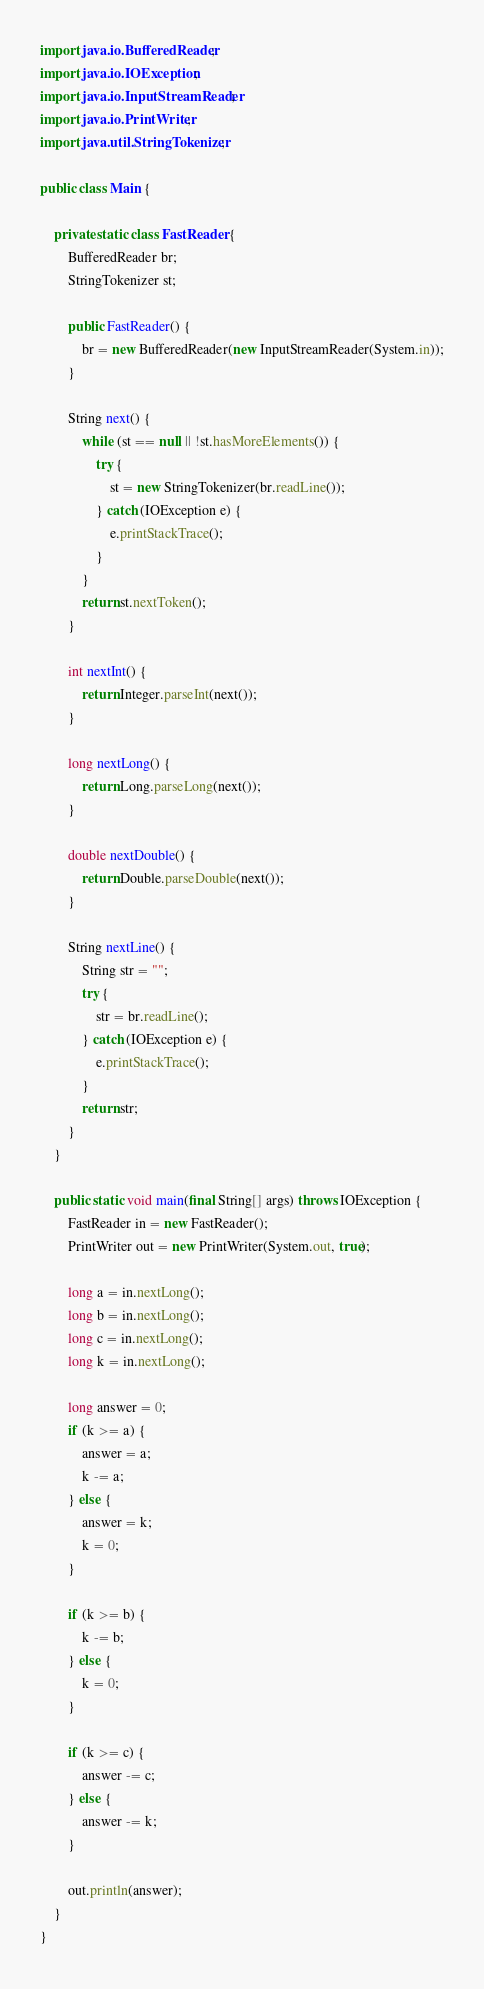Convert code to text. <code><loc_0><loc_0><loc_500><loc_500><_Java_>import java.io.BufferedReader;
import java.io.IOException;
import java.io.InputStreamReader;
import java.io.PrintWriter;
import java.util.StringTokenizer;

public class Main {

    private static class FastReader {
        BufferedReader br;
        StringTokenizer st;

        public FastReader() {
            br = new BufferedReader(new InputStreamReader(System.in));
        }

        String next() {
            while (st == null || !st.hasMoreElements()) {
                try {
                    st = new StringTokenizer(br.readLine());
                } catch (IOException e) {
                    e.printStackTrace();
                }
            }
            return st.nextToken();
        }

        int nextInt() {
            return Integer.parseInt(next());
        }

        long nextLong() {
            return Long.parseLong(next());
        }

        double nextDouble() {
            return Double.parseDouble(next());
        }

        String nextLine() {
            String str = "";
            try {
                str = br.readLine();
            } catch (IOException e) {
                e.printStackTrace();
            }
            return str;
        }
    }

    public static void main(final String[] args) throws IOException {
        FastReader in = new FastReader();
        PrintWriter out = new PrintWriter(System.out, true);

        long a = in.nextLong();
        long b = in.nextLong();
        long c = in.nextLong();
        long k = in.nextLong();

        long answer = 0;
        if (k >= a) {
            answer = a;
            k -= a;
        } else {
            answer = k;
            k = 0;
        }

        if (k >= b) {
            k -= b;
        } else {
            k = 0;
        }

        if (k >= c) {
            answer -= c;
        } else {
            answer -= k;
        }

        out.println(answer);
    }
}
</code> 